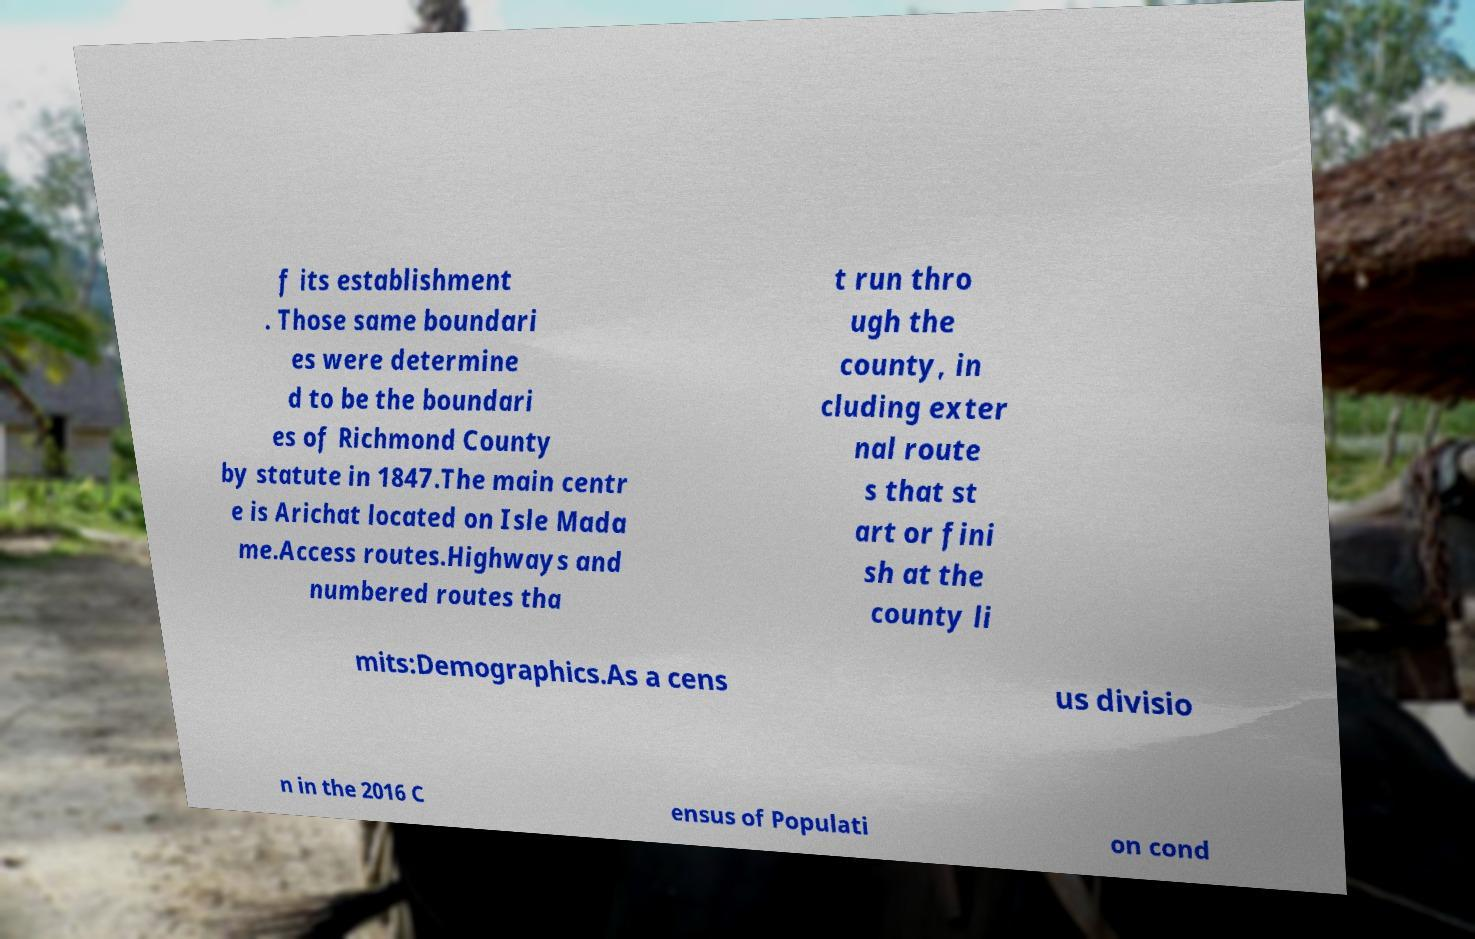Can you read and provide the text displayed in the image?This photo seems to have some interesting text. Can you extract and type it out for me? f its establishment . Those same boundari es were determine d to be the boundari es of Richmond County by statute in 1847.The main centr e is Arichat located on Isle Mada me.Access routes.Highways and numbered routes tha t run thro ugh the county, in cluding exter nal route s that st art or fini sh at the county li mits:Demographics.As a cens us divisio n in the 2016 C ensus of Populati on cond 